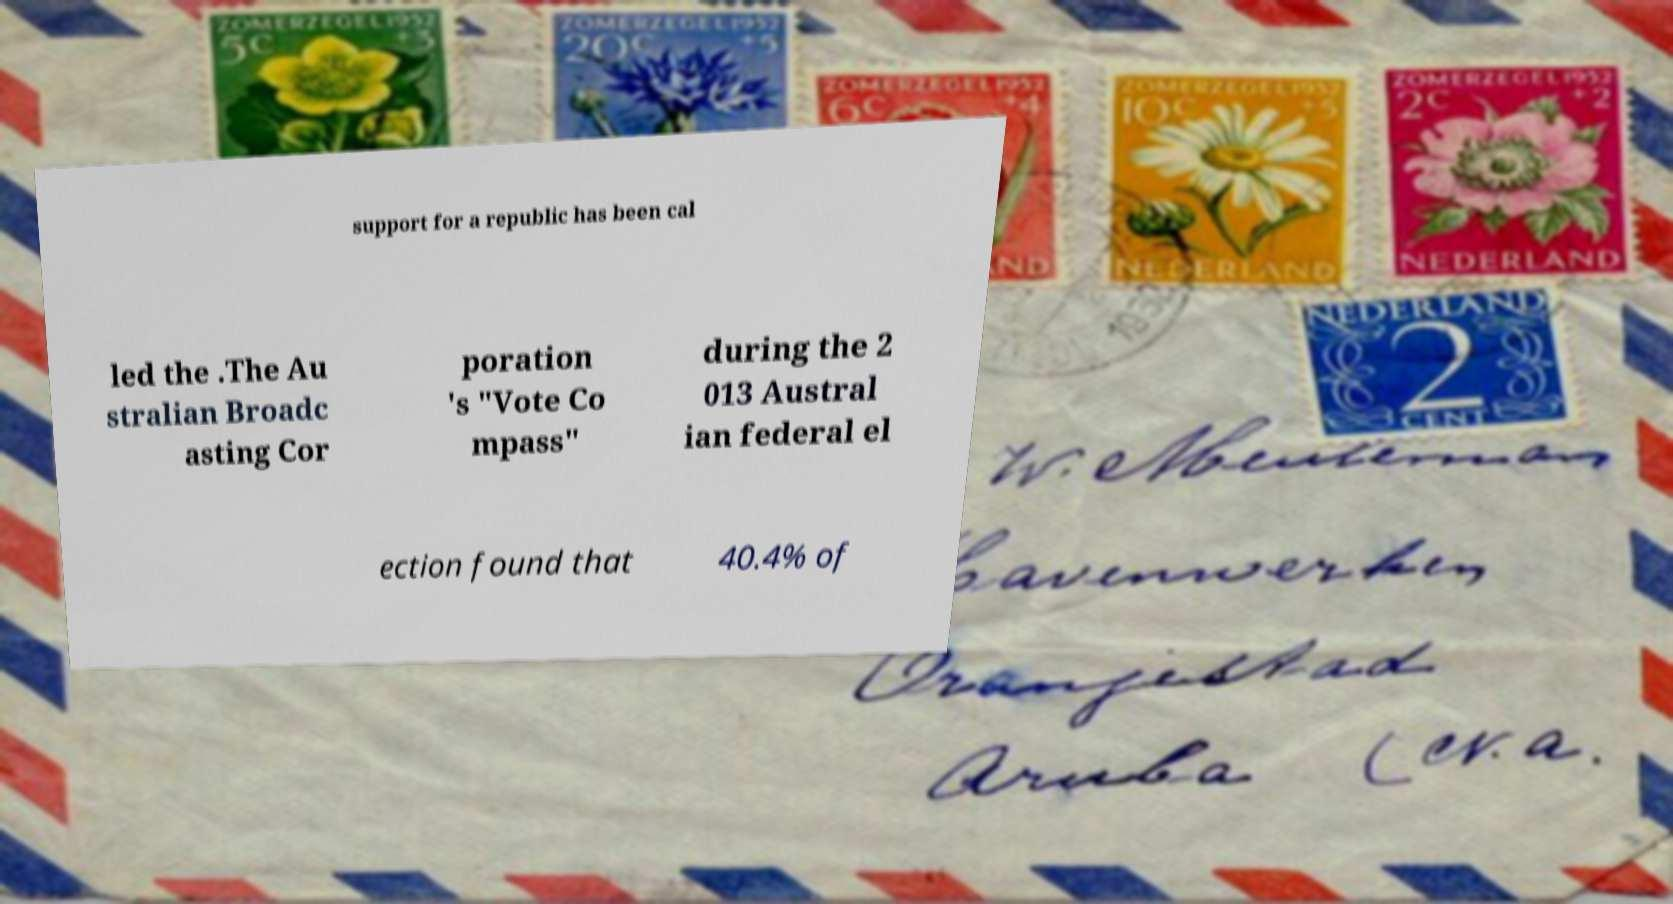I need the written content from this picture converted into text. Can you do that? support for a republic has been cal led the .The Au stralian Broadc asting Cor poration 's "Vote Co mpass" during the 2 013 Austral ian federal el ection found that 40.4% of 